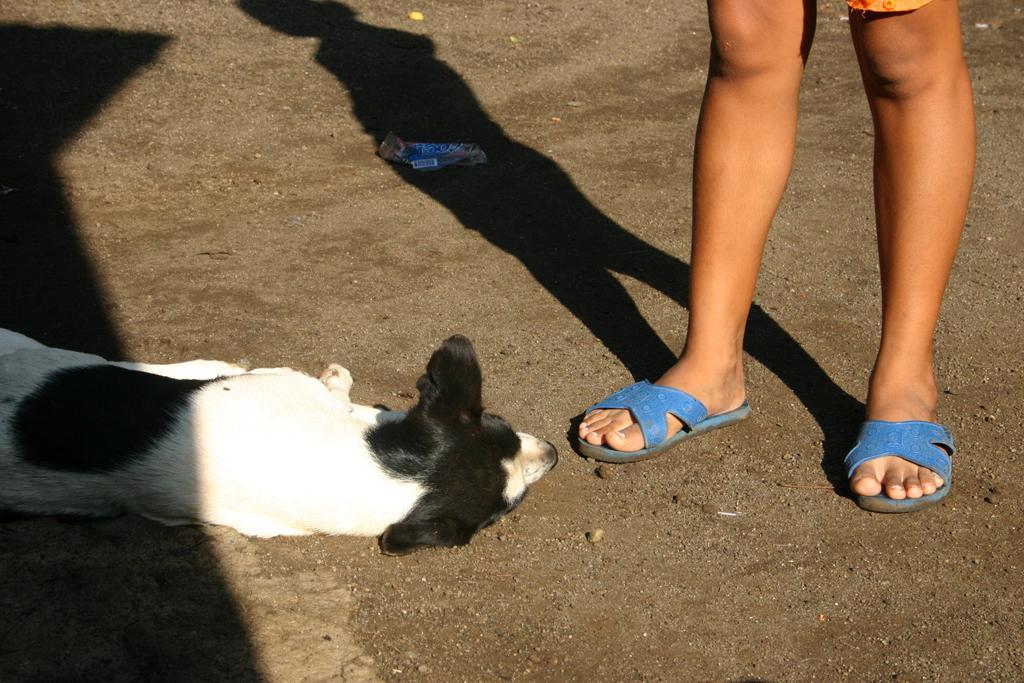Can you describe this image briefly? In the foreground of the picture we can see a person´s legs and dog lying on the ground. 